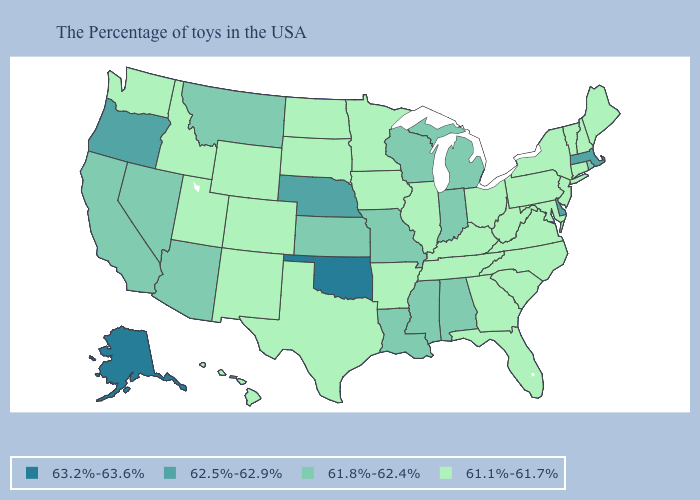Which states have the highest value in the USA?
Give a very brief answer. Oklahoma, Alaska. What is the highest value in states that border Nebraska?
Be succinct. 61.8%-62.4%. Which states have the lowest value in the Northeast?
Concise answer only. Maine, New Hampshire, Vermont, Connecticut, New York, New Jersey, Pennsylvania. What is the value of Delaware?
Give a very brief answer. 62.5%-62.9%. Does Maryland have the lowest value in the USA?
Give a very brief answer. Yes. Which states have the highest value in the USA?
Be succinct. Oklahoma, Alaska. What is the value of Rhode Island?
Give a very brief answer. 61.8%-62.4%. Which states have the lowest value in the West?
Write a very short answer. Wyoming, Colorado, New Mexico, Utah, Idaho, Washington, Hawaii. What is the value of Oregon?
Write a very short answer. 62.5%-62.9%. Name the states that have a value in the range 61.8%-62.4%?
Write a very short answer. Rhode Island, Michigan, Indiana, Alabama, Wisconsin, Mississippi, Louisiana, Missouri, Kansas, Montana, Arizona, Nevada, California. Which states have the lowest value in the MidWest?
Short answer required. Ohio, Illinois, Minnesota, Iowa, South Dakota, North Dakota. Is the legend a continuous bar?
Give a very brief answer. No. Which states hav the highest value in the Northeast?
Write a very short answer. Massachusetts. Which states have the highest value in the USA?
Keep it brief. Oklahoma, Alaska. 